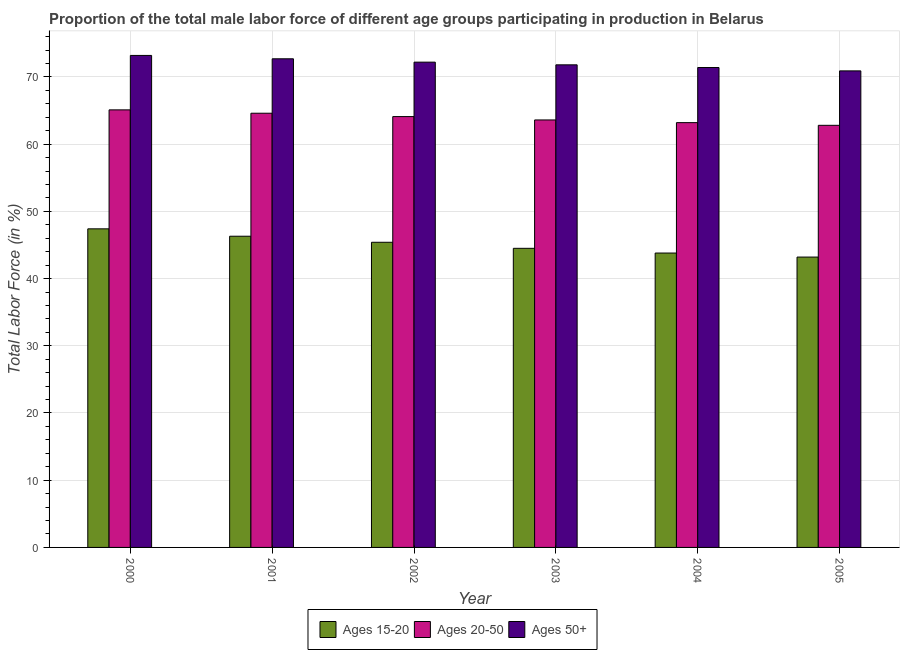Are the number of bars per tick equal to the number of legend labels?
Provide a short and direct response. Yes. Are the number of bars on each tick of the X-axis equal?
Give a very brief answer. Yes. How many bars are there on the 6th tick from the left?
Provide a succinct answer. 3. How many bars are there on the 4th tick from the right?
Make the answer very short. 3. What is the label of the 6th group of bars from the left?
Your answer should be compact. 2005. What is the percentage of male labor force above age 50 in 2005?
Ensure brevity in your answer.  70.9. Across all years, what is the maximum percentage of male labor force within the age group 15-20?
Provide a succinct answer. 47.4. Across all years, what is the minimum percentage of male labor force within the age group 15-20?
Offer a very short reply. 43.2. In which year was the percentage of male labor force within the age group 20-50 maximum?
Your answer should be compact. 2000. In which year was the percentage of male labor force within the age group 15-20 minimum?
Ensure brevity in your answer.  2005. What is the total percentage of male labor force above age 50 in the graph?
Offer a terse response. 432.2. What is the difference between the percentage of male labor force above age 50 in 2001 and that in 2002?
Provide a short and direct response. 0.5. What is the average percentage of male labor force within the age group 20-50 per year?
Your response must be concise. 63.9. What is the ratio of the percentage of male labor force within the age group 15-20 in 2003 to that in 2004?
Provide a succinct answer. 1.02. Is the percentage of male labor force within the age group 20-50 in 2002 less than that in 2005?
Your response must be concise. No. Is the difference between the percentage of male labor force within the age group 20-50 in 2004 and 2005 greater than the difference between the percentage of male labor force above age 50 in 2004 and 2005?
Provide a short and direct response. No. What is the difference between the highest and the lowest percentage of male labor force within the age group 15-20?
Your answer should be very brief. 4.2. Is the sum of the percentage of male labor force within the age group 20-50 in 2000 and 2004 greater than the maximum percentage of male labor force within the age group 15-20 across all years?
Your answer should be very brief. Yes. What does the 1st bar from the left in 2001 represents?
Your response must be concise. Ages 15-20. What does the 3rd bar from the right in 2002 represents?
Provide a short and direct response. Ages 15-20. How many bars are there?
Your answer should be compact. 18. How many years are there in the graph?
Ensure brevity in your answer.  6. Are the values on the major ticks of Y-axis written in scientific E-notation?
Ensure brevity in your answer.  No. Does the graph contain grids?
Your response must be concise. Yes. How many legend labels are there?
Your answer should be very brief. 3. What is the title of the graph?
Your answer should be very brief. Proportion of the total male labor force of different age groups participating in production in Belarus. What is the label or title of the X-axis?
Your response must be concise. Year. What is the label or title of the Y-axis?
Your response must be concise. Total Labor Force (in %). What is the Total Labor Force (in %) of Ages 15-20 in 2000?
Your response must be concise. 47.4. What is the Total Labor Force (in %) of Ages 20-50 in 2000?
Ensure brevity in your answer.  65.1. What is the Total Labor Force (in %) of Ages 50+ in 2000?
Provide a short and direct response. 73.2. What is the Total Labor Force (in %) of Ages 15-20 in 2001?
Your response must be concise. 46.3. What is the Total Labor Force (in %) in Ages 20-50 in 2001?
Provide a succinct answer. 64.6. What is the Total Labor Force (in %) of Ages 50+ in 2001?
Keep it short and to the point. 72.7. What is the Total Labor Force (in %) of Ages 15-20 in 2002?
Offer a very short reply. 45.4. What is the Total Labor Force (in %) of Ages 20-50 in 2002?
Your response must be concise. 64.1. What is the Total Labor Force (in %) of Ages 50+ in 2002?
Make the answer very short. 72.2. What is the Total Labor Force (in %) in Ages 15-20 in 2003?
Your answer should be very brief. 44.5. What is the Total Labor Force (in %) in Ages 20-50 in 2003?
Give a very brief answer. 63.6. What is the Total Labor Force (in %) in Ages 50+ in 2003?
Provide a short and direct response. 71.8. What is the Total Labor Force (in %) in Ages 15-20 in 2004?
Your answer should be compact. 43.8. What is the Total Labor Force (in %) in Ages 20-50 in 2004?
Ensure brevity in your answer.  63.2. What is the Total Labor Force (in %) of Ages 50+ in 2004?
Ensure brevity in your answer.  71.4. What is the Total Labor Force (in %) in Ages 15-20 in 2005?
Provide a short and direct response. 43.2. What is the Total Labor Force (in %) in Ages 20-50 in 2005?
Offer a very short reply. 62.8. What is the Total Labor Force (in %) in Ages 50+ in 2005?
Your response must be concise. 70.9. Across all years, what is the maximum Total Labor Force (in %) of Ages 15-20?
Offer a terse response. 47.4. Across all years, what is the maximum Total Labor Force (in %) of Ages 20-50?
Ensure brevity in your answer.  65.1. Across all years, what is the maximum Total Labor Force (in %) in Ages 50+?
Your answer should be compact. 73.2. Across all years, what is the minimum Total Labor Force (in %) in Ages 15-20?
Your response must be concise. 43.2. Across all years, what is the minimum Total Labor Force (in %) of Ages 20-50?
Your answer should be compact. 62.8. Across all years, what is the minimum Total Labor Force (in %) in Ages 50+?
Give a very brief answer. 70.9. What is the total Total Labor Force (in %) of Ages 15-20 in the graph?
Make the answer very short. 270.6. What is the total Total Labor Force (in %) of Ages 20-50 in the graph?
Offer a terse response. 383.4. What is the total Total Labor Force (in %) in Ages 50+ in the graph?
Make the answer very short. 432.2. What is the difference between the Total Labor Force (in %) in Ages 15-20 in 2000 and that in 2001?
Ensure brevity in your answer.  1.1. What is the difference between the Total Labor Force (in %) of Ages 50+ in 2000 and that in 2001?
Your answer should be very brief. 0.5. What is the difference between the Total Labor Force (in %) in Ages 20-50 in 2000 and that in 2002?
Make the answer very short. 1. What is the difference between the Total Labor Force (in %) in Ages 50+ in 2000 and that in 2002?
Give a very brief answer. 1. What is the difference between the Total Labor Force (in %) in Ages 15-20 in 2000 and that in 2003?
Your response must be concise. 2.9. What is the difference between the Total Labor Force (in %) in Ages 20-50 in 2000 and that in 2003?
Keep it short and to the point. 1.5. What is the difference between the Total Labor Force (in %) in Ages 50+ in 2000 and that in 2003?
Provide a short and direct response. 1.4. What is the difference between the Total Labor Force (in %) of Ages 15-20 in 2000 and that in 2005?
Your answer should be very brief. 4.2. What is the difference between the Total Labor Force (in %) of Ages 20-50 in 2000 and that in 2005?
Give a very brief answer. 2.3. What is the difference between the Total Labor Force (in %) in Ages 50+ in 2000 and that in 2005?
Your answer should be very brief. 2.3. What is the difference between the Total Labor Force (in %) of Ages 50+ in 2001 and that in 2002?
Your response must be concise. 0.5. What is the difference between the Total Labor Force (in %) of Ages 15-20 in 2001 and that in 2003?
Provide a short and direct response. 1.8. What is the difference between the Total Labor Force (in %) in Ages 50+ in 2001 and that in 2003?
Offer a terse response. 0.9. What is the difference between the Total Labor Force (in %) in Ages 20-50 in 2001 and that in 2004?
Your answer should be very brief. 1.4. What is the difference between the Total Labor Force (in %) of Ages 15-20 in 2001 and that in 2005?
Make the answer very short. 3.1. What is the difference between the Total Labor Force (in %) in Ages 20-50 in 2001 and that in 2005?
Ensure brevity in your answer.  1.8. What is the difference between the Total Labor Force (in %) in Ages 15-20 in 2002 and that in 2003?
Ensure brevity in your answer.  0.9. What is the difference between the Total Labor Force (in %) of Ages 50+ in 2002 and that in 2004?
Offer a very short reply. 0.8. What is the difference between the Total Labor Force (in %) in Ages 50+ in 2002 and that in 2005?
Your answer should be compact. 1.3. What is the difference between the Total Labor Force (in %) in Ages 50+ in 2003 and that in 2004?
Make the answer very short. 0.4. What is the difference between the Total Labor Force (in %) of Ages 15-20 in 2003 and that in 2005?
Make the answer very short. 1.3. What is the difference between the Total Labor Force (in %) in Ages 50+ in 2003 and that in 2005?
Ensure brevity in your answer.  0.9. What is the difference between the Total Labor Force (in %) of Ages 15-20 in 2000 and the Total Labor Force (in %) of Ages 20-50 in 2001?
Provide a succinct answer. -17.2. What is the difference between the Total Labor Force (in %) in Ages 15-20 in 2000 and the Total Labor Force (in %) in Ages 50+ in 2001?
Make the answer very short. -25.3. What is the difference between the Total Labor Force (in %) of Ages 15-20 in 2000 and the Total Labor Force (in %) of Ages 20-50 in 2002?
Provide a short and direct response. -16.7. What is the difference between the Total Labor Force (in %) of Ages 15-20 in 2000 and the Total Labor Force (in %) of Ages 50+ in 2002?
Provide a succinct answer. -24.8. What is the difference between the Total Labor Force (in %) of Ages 15-20 in 2000 and the Total Labor Force (in %) of Ages 20-50 in 2003?
Provide a short and direct response. -16.2. What is the difference between the Total Labor Force (in %) in Ages 15-20 in 2000 and the Total Labor Force (in %) in Ages 50+ in 2003?
Your answer should be compact. -24.4. What is the difference between the Total Labor Force (in %) of Ages 20-50 in 2000 and the Total Labor Force (in %) of Ages 50+ in 2003?
Your response must be concise. -6.7. What is the difference between the Total Labor Force (in %) in Ages 15-20 in 2000 and the Total Labor Force (in %) in Ages 20-50 in 2004?
Your response must be concise. -15.8. What is the difference between the Total Labor Force (in %) in Ages 15-20 in 2000 and the Total Labor Force (in %) in Ages 50+ in 2004?
Your answer should be compact. -24. What is the difference between the Total Labor Force (in %) of Ages 15-20 in 2000 and the Total Labor Force (in %) of Ages 20-50 in 2005?
Your response must be concise. -15.4. What is the difference between the Total Labor Force (in %) in Ages 15-20 in 2000 and the Total Labor Force (in %) in Ages 50+ in 2005?
Keep it short and to the point. -23.5. What is the difference between the Total Labor Force (in %) in Ages 15-20 in 2001 and the Total Labor Force (in %) in Ages 20-50 in 2002?
Offer a very short reply. -17.8. What is the difference between the Total Labor Force (in %) in Ages 15-20 in 2001 and the Total Labor Force (in %) in Ages 50+ in 2002?
Give a very brief answer. -25.9. What is the difference between the Total Labor Force (in %) of Ages 20-50 in 2001 and the Total Labor Force (in %) of Ages 50+ in 2002?
Offer a terse response. -7.6. What is the difference between the Total Labor Force (in %) of Ages 15-20 in 2001 and the Total Labor Force (in %) of Ages 20-50 in 2003?
Give a very brief answer. -17.3. What is the difference between the Total Labor Force (in %) of Ages 15-20 in 2001 and the Total Labor Force (in %) of Ages 50+ in 2003?
Your answer should be compact. -25.5. What is the difference between the Total Labor Force (in %) in Ages 15-20 in 2001 and the Total Labor Force (in %) in Ages 20-50 in 2004?
Your response must be concise. -16.9. What is the difference between the Total Labor Force (in %) of Ages 15-20 in 2001 and the Total Labor Force (in %) of Ages 50+ in 2004?
Make the answer very short. -25.1. What is the difference between the Total Labor Force (in %) in Ages 20-50 in 2001 and the Total Labor Force (in %) in Ages 50+ in 2004?
Your answer should be compact. -6.8. What is the difference between the Total Labor Force (in %) of Ages 15-20 in 2001 and the Total Labor Force (in %) of Ages 20-50 in 2005?
Offer a very short reply. -16.5. What is the difference between the Total Labor Force (in %) in Ages 15-20 in 2001 and the Total Labor Force (in %) in Ages 50+ in 2005?
Offer a very short reply. -24.6. What is the difference between the Total Labor Force (in %) in Ages 20-50 in 2001 and the Total Labor Force (in %) in Ages 50+ in 2005?
Provide a short and direct response. -6.3. What is the difference between the Total Labor Force (in %) in Ages 15-20 in 2002 and the Total Labor Force (in %) in Ages 20-50 in 2003?
Your answer should be very brief. -18.2. What is the difference between the Total Labor Force (in %) of Ages 15-20 in 2002 and the Total Labor Force (in %) of Ages 50+ in 2003?
Keep it short and to the point. -26.4. What is the difference between the Total Labor Force (in %) of Ages 15-20 in 2002 and the Total Labor Force (in %) of Ages 20-50 in 2004?
Give a very brief answer. -17.8. What is the difference between the Total Labor Force (in %) in Ages 15-20 in 2002 and the Total Labor Force (in %) in Ages 50+ in 2004?
Give a very brief answer. -26. What is the difference between the Total Labor Force (in %) of Ages 15-20 in 2002 and the Total Labor Force (in %) of Ages 20-50 in 2005?
Offer a very short reply. -17.4. What is the difference between the Total Labor Force (in %) of Ages 15-20 in 2002 and the Total Labor Force (in %) of Ages 50+ in 2005?
Your answer should be very brief. -25.5. What is the difference between the Total Labor Force (in %) of Ages 15-20 in 2003 and the Total Labor Force (in %) of Ages 20-50 in 2004?
Provide a short and direct response. -18.7. What is the difference between the Total Labor Force (in %) of Ages 15-20 in 2003 and the Total Labor Force (in %) of Ages 50+ in 2004?
Provide a short and direct response. -26.9. What is the difference between the Total Labor Force (in %) in Ages 15-20 in 2003 and the Total Labor Force (in %) in Ages 20-50 in 2005?
Your answer should be very brief. -18.3. What is the difference between the Total Labor Force (in %) in Ages 15-20 in 2003 and the Total Labor Force (in %) in Ages 50+ in 2005?
Your answer should be compact. -26.4. What is the difference between the Total Labor Force (in %) of Ages 15-20 in 2004 and the Total Labor Force (in %) of Ages 50+ in 2005?
Offer a very short reply. -27.1. What is the average Total Labor Force (in %) in Ages 15-20 per year?
Provide a short and direct response. 45.1. What is the average Total Labor Force (in %) of Ages 20-50 per year?
Offer a terse response. 63.9. What is the average Total Labor Force (in %) of Ages 50+ per year?
Ensure brevity in your answer.  72.03. In the year 2000, what is the difference between the Total Labor Force (in %) of Ages 15-20 and Total Labor Force (in %) of Ages 20-50?
Provide a succinct answer. -17.7. In the year 2000, what is the difference between the Total Labor Force (in %) in Ages 15-20 and Total Labor Force (in %) in Ages 50+?
Offer a terse response. -25.8. In the year 2001, what is the difference between the Total Labor Force (in %) in Ages 15-20 and Total Labor Force (in %) in Ages 20-50?
Offer a very short reply. -18.3. In the year 2001, what is the difference between the Total Labor Force (in %) of Ages 15-20 and Total Labor Force (in %) of Ages 50+?
Offer a terse response. -26.4. In the year 2001, what is the difference between the Total Labor Force (in %) in Ages 20-50 and Total Labor Force (in %) in Ages 50+?
Keep it short and to the point. -8.1. In the year 2002, what is the difference between the Total Labor Force (in %) of Ages 15-20 and Total Labor Force (in %) of Ages 20-50?
Provide a short and direct response. -18.7. In the year 2002, what is the difference between the Total Labor Force (in %) of Ages 15-20 and Total Labor Force (in %) of Ages 50+?
Make the answer very short. -26.8. In the year 2002, what is the difference between the Total Labor Force (in %) in Ages 20-50 and Total Labor Force (in %) in Ages 50+?
Give a very brief answer. -8.1. In the year 2003, what is the difference between the Total Labor Force (in %) in Ages 15-20 and Total Labor Force (in %) in Ages 20-50?
Your response must be concise. -19.1. In the year 2003, what is the difference between the Total Labor Force (in %) of Ages 15-20 and Total Labor Force (in %) of Ages 50+?
Provide a short and direct response. -27.3. In the year 2004, what is the difference between the Total Labor Force (in %) in Ages 15-20 and Total Labor Force (in %) in Ages 20-50?
Your response must be concise. -19.4. In the year 2004, what is the difference between the Total Labor Force (in %) of Ages 15-20 and Total Labor Force (in %) of Ages 50+?
Provide a short and direct response. -27.6. In the year 2004, what is the difference between the Total Labor Force (in %) in Ages 20-50 and Total Labor Force (in %) in Ages 50+?
Your answer should be very brief. -8.2. In the year 2005, what is the difference between the Total Labor Force (in %) of Ages 15-20 and Total Labor Force (in %) of Ages 20-50?
Offer a terse response. -19.6. In the year 2005, what is the difference between the Total Labor Force (in %) of Ages 15-20 and Total Labor Force (in %) of Ages 50+?
Your response must be concise. -27.7. What is the ratio of the Total Labor Force (in %) of Ages 15-20 in 2000 to that in 2001?
Ensure brevity in your answer.  1.02. What is the ratio of the Total Labor Force (in %) of Ages 20-50 in 2000 to that in 2001?
Provide a short and direct response. 1.01. What is the ratio of the Total Labor Force (in %) of Ages 50+ in 2000 to that in 2001?
Your answer should be compact. 1.01. What is the ratio of the Total Labor Force (in %) in Ages 15-20 in 2000 to that in 2002?
Make the answer very short. 1.04. What is the ratio of the Total Labor Force (in %) in Ages 20-50 in 2000 to that in 2002?
Your answer should be very brief. 1.02. What is the ratio of the Total Labor Force (in %) in Ages 50+ in 2000 to that in 2002?
Make the answer very short. 1.01. What is the ratio of the Total Labor Force (in %) in Ages 15-20 in 2000 to that in 2003?
Offer a very short reply. 1.07. What is the ratio of the Total Labor Force (in %) in Ages 20-50 in 2000 to that in 2003?
Give a very brief answer. 1.02. What is the ratio of the Total Labor Force (in %) of Ages 50+ in 2000 to that in 2003?
Give a very brief answer. 1.02. What is the ratio of the Total Labor Force (in %) of Ages 15-20 in 2000 to that in 2004?
Your response must be concise. 1.08. What is the ratio of the Total Labor Force (in %) of Ages 20-50 in 2000 to that in 2004?
Ensure brevity in your answer.  1.03. What is the ratio of the Total Labor Force (in %) in Ages 50+ in 2000 to that in 2004?
Offer a terse response. 1.03. What is the ratio of the Total Labor Force (in %) in Ages 15-20 in 2000 to that in 2005?
Your answer should be very brief. 1.1. What is the ratio of the Total Labor Force (in %) of Ages 20-50 in 2000 to that in 2005?
Offer a very short reply. 1.04. What is the ratio of the Total Labor Force (in %) in Ages 50+ in 2000 to that in 2005?
Your response must be concise. 1.03. What is the ratio of the Total Labor Force (in %) of Ages 15-20 in 2001 to that in 2002?
Give a very brief answer. 1.02. What is the ratio of the Total Labor Force (in %) in Ages 15-20 in 2001 to that in 2003?
Your answer should be very brief. 1.04. What is the ratio of the Total Labor Force (in %) in Ages 20-50 in 2001 to that in 2003?
Your response must be concise. 1.02. What is the ratio of the Total Labor Force (in %) in Ages 50+ in 2001 to that in 2003?
Your answer should be compact. 1.01. What is the ratio of the Total Labor Force (in %) in Ages 15-20 in 2001 to that in 2004?
Provide a short and direct response. 1.06. What is the ratio of the Total Labor Force (in %) in Ages 20-50 in 2001 to that in 2004?
Provide a short and direct response. 1.02. What is the ratio of the Total Labor Force (in %) in Ages 50+ in 2001 to that in 2004?
Your answer should be compact. 1.02. What is the ratio of the Total Labor Force (in %) in Ages 15-20 in 2001 to that in 2005?
Your answer should be very brief. 1.07. What is the ratio of the Total Labor Force (in %) of Ages 20-50 in 2001 to that in 2005?
Offer a terse response. 1.03. What is the ratio of the Total Labor Force (in %) of Ages 50+ in 2001 to that in 2005?
Your answer should be compact. 1.03. What is the ratio of the Total Labor Force (in %) in Ages 15-20 in 2002 to that in 2003?
Your answer should be compact. 1.02. What is the ratio of the Total Labor Force (in %) in Ages 20-50 in 2002 to that in 2003?
Offer a terse response. 1.01. What is the ratio of the Total Labor Force (in %) of Ages 50+ in 2002 to that in 2003?
Offer a terse response. 1.01. What is the ratio of the Total Labor Force (in %) in Ages 15-20 in 2002 to that in 2004?
Your answer should be very brief. 1.04. What is the ratio of the Total Labor Force (in %) of Ages 20-50 in 2002 to that in 2004?
Provide a short and direct response. 1.01. What is the ratio of the Total Labor Force (in %) in Ages 50+ in 2002 to that in 2004?
Make the answer very short. 1.01. What is the ratio of the Total Labor Force (in %) in Ages 15-20 in 2002 to that in 2005?
Provide a succinct answer. 1.05. What is the ratio of the Total Labor Force (in %) in Ages 20-50 in 2002 to that in 2005?
Your answer should be compact. 1.02. What is the ratio of the Total Labor Force (in %) of Ages 50+ in 2002 to that in 2005?
Give a very brief answer. 1.02. What is the ratio of the Total Labor Force (in %) of Ages 15-20 in 2003 to that in 2004?
Your response must be concise. 1.02. What is the ratio of the Total Labor Force (in %) in Ages 20-50 in 2003 to that in 2004?
Offer a terse response. 1.01. What is the ratio of the Total Labor Force (in %) in Ages 50+ in 2003 to that in 2004?
Keep it short and to the point. 1.01. What is the ratio of the Total Labor Force (in %) of Ages 15-20 in 2003 to that in 2005?
Ensure brevity in your answer.  1.03. What is the ratio of the Total Labor Force (in %) of Ages 20-50 in 2003 to that in 2005?
Your answer should be compact. 1.01. What is the ratio of the Total Labor Force (in %) in Ages 50+ in 2003 to that in 2005?
Give a very brief answer. 1.01. What is the ratio of the Total Labor Force (in %) of Ages 15-20 in 2004 to that in 2005?
Provide a succinct answer. 1.01. What is the ratio of the Total Labor Force (in %) of Ages 20-50 in 2004 to that in 2005?
Provide a succinct answer. 1.01. What is the ratio of the Total Labor Force (in %) in Ages 50+ in 2004 to that in 2005?
Keep it short and to the point. 1.01. What is the difference between the highest and the second highest Total Labor Force (in %) in Ages 15-20?
Your answer should be very brief. 1.1. What is the difference between the highest and the second highest Total Labor Force (in %) of Ages 50+?
Offer a terse response. 0.5. What is the difference between the highest and the lowest Total Labor Force (in %) of Ages 15-20?
Provide a short and direct response. 4.2. What is the difference between the highest and the lowest Total Labor Force (in %) of Ages 20-50?
Keep it short and to the point. 2.3. What is the difference between the highest and the lowest Total Labor Force (in %) in Ages 50+?
Provide a succinct answer. 2.3. 